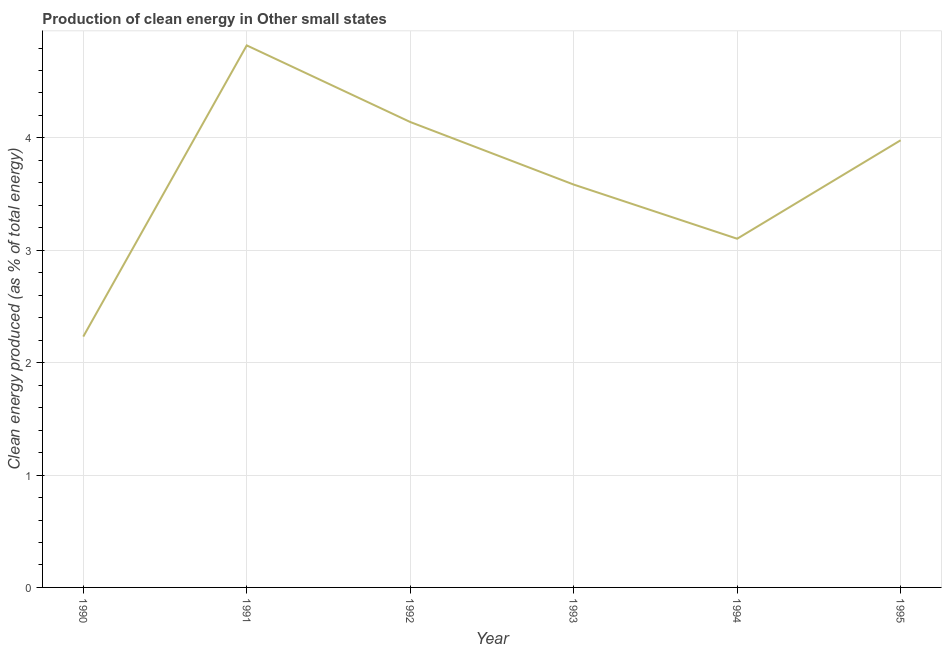What is the production of clean energy in 1993?
Give a very brief answer. 3.59. Across all years, what is the maximum production of clean energy?
Provide a succinct answer. 4.82. Across all years, what is the minimum production of clean energy?
Keep it short and to the point. 2.23. What is the sum of the production of clean energy?
Your answer should be very brief. 21.86. What is the difference between the production of clean energy in 1991 and 1995?
Provide a succinct answer. 0.84. What is the average production of clean energy per year?
Provide a succinct answer. 3.64. What is the median production of clean energy?
Your answer should be very brief. 3.78. In how many years, is the production of clean energy greater than 1.4 %?
Make the answer very short. 6. What is the ratio of the production of clean energy in 1992 to that in 1994?
Provide a short and direct response. 1.33. What is the difference between the highest and the second highest production of clean energy?
Provide a succinct answer. 0.68. What is the difference between the highest and the lowest production of clean energy?
Your answer should be compact. 2.59. How many lines are there?
Ensure brevity in your answer.  1. How many years are there in the graph?
Offer a terse response. 6. What is the difference between two consecutive major ticks on the Y-axis?
Your answer should be very brief. 1. Are the values on the major ticks of Y-axis written in scientific E-notation?
Your answer should be compact. No. Does the graph contain any zero values?
Provide a succinct answer. No. Does the graph contain grids?
Keep it short and to the point. Yes. What is the title of the graph?
Offer a very short reply. Production of clean energy in Other small states. What is the label or title of the Y-axis?
Give a very brief answer. Clean energy produced (as % of total energy). What is the Clean energy produced (as % of total energy) in 1990?
Your answer should be compact. 2.23. What is the Clean energy produced (as % of total energy) in 1991?
Offer a very short reply. 4.82. What is the Clean energy produced (as % of total energy) of 1992?
Ensure brevity in your answer.  4.14. What is the Clean energy produced (as % of total energy) in 1993?
Ensure brevity in your answer.  3.59. What is the Clean energy produced (as % of total energy) of 1994?
Make the answer very short. 3.1. What is the Clean energy produced (as % of total energy) of 1995?
Give a very brief answer. 3.98. What is the difference between the Clean energy produced (as % of total energy) in 1990 and 1991?
Make the answer very short. -2.59. What is the difference between the Clean energy produced (as % of total energy) in 1990 and 1992?
Ensure brevity in your answer.  -1.91. What is the difference between the Clean energy produced (as % of total energy) in 1990 and 1993?
Your response must be concise. -1.35. What is the difference between the Clean energy produced (as % of total energy) in 1990 and 1994?
Your answer should be compact. -0.87. What is the difference between the Clean energy produced (as % of total energy) in 1990 and 1995?
Ensure brevity in your answer.  -1.75. What is the difference between the Clean energy produced (as % of total energy) in 1991 and 1992?
Offer a very short reply. 0.68. What is the difference between the Clean energy produced (as % of total energy) in 1991 and 1993?
Give a very brief answer. 1.24. What is the difference between the Clean energy produced (as % of total energy) in 1991 and 1994?
Keep it short and to the point. 1.72. What is the difference between the Clean energy produced (as % of total energy) in 1991 and 1995?
Give a very brief answer. 0.84. What is the difference between the Clean energy produced (as % of total energy) in 1992 and 1993?
Ensure brevity in your answer.  0.56. What is the difference between the Clean energy produced (as % of total energy) in 1992 and 1994?
Offer a terse response. 1.04. What is the difference between the Clean energy produced (as % of total energy) in 1992 and 1995?
Your response must be concise. 0.16. What is the difference between the Clean energy produced (as % of total energy) in 1993 and 1994?
Provide a succinct answer. 0.48. What is the difference between the Clean energy produced (as % of total energy) in 1993 and 1995?
Your answer should be very brief. -0.39. What is the difference between the Clean energy produced (as % of total energy) in 1994 and 1995?
Your answer should be compact. -0.88. What is the ratio of the Clean energy produced (as % of total energy) in 1990 to that in 1991?
Make the answer very short. 0.46. What is the ratio of the Clean energy produced (as % of total energy) in 1990 to that in 1992?
Make the answer very short. 0.54. What is the ratio of the Clean energy produced (as % of total energy) in 1990 to that in 1993?
Offer a terse response. 0.62. What is the ratio of the Clean energy produced (as % of total energy) in 1990 to that in 1994?
Ensure brevity in your answer.  0.72. What is the ratio of the Clean energy produced (as % of total energy) in 1990 to that in 1995?
Provide a short and direct response. 0.56. What is the ratio of the Clean energy produced (as % of total energy) in 1991 to that in 1992?
Provide a succinct answer. 1.17. What is the ratio of the Clean energy produced (as % of total energy) in 1991 to that in 1993?
Your answer should be compact. 1.34. What is the ratio of the Clean energy produced (as % of total energy) in 1991 to that in 1994?
Your answer should be very brief. 1.55. What is the ratio of the Clean energy produced (as % of total energy) in 1991 to that in 1995?
Your answer should be compact. 1.21. What is the ratio of the Clean energy produced (as % of total energy) in 1992 to that in 1993?
Provide a succinct answer. 1.16. What is the ratio of the Clean energy produced (as % of total energy) in 1992 to that in 1994?
Make the answer very short. 1.33. What is the ratio of the Clean energy produced (as % of total energy) in 1992 to that in 1995?
Your answer should be very brief. 1.04. What is the ratio of the Clean energy produced (as % of total energy) in 1993 to that in 1994?
Offer a terse response. 1.16. What is the ratio of the Clean energy produced (as % of total energy) in 1993 to that in 1995?
Provide a succinct answer. 0.9. What is the ratio of the Clean energy produced (as % of total energy) in 1994 to that in 1995?
Offer a terse response. 0.78. 